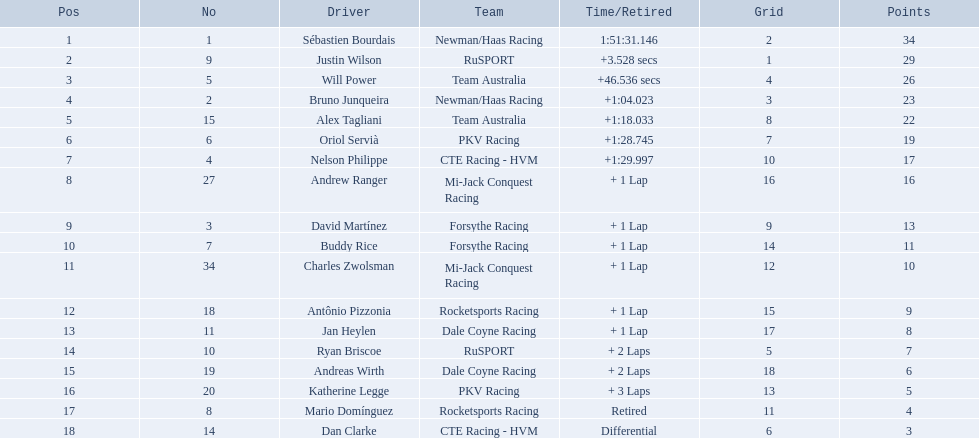Who are all of the 2006 gran premio telmex drivers? Sébastien Bourdais, Justin Wilson, Will Power, Bruno Junqueira, Alex Tagliani, Oriol Servià, Nelson Philippe, Andrew Ranger, David Martínez, Buddy Rice, Charles Zwolsman, Antônio Pizzonia, Jan Heylen, Ryan Briscoe, Andreas Wirth, Katherine Legge, Mario Domínguez, Dan Clarke. How many laps did they finish? 66, 66, 66, 66, 66, 66, 66, 65, 65, 65, 65, 65, 65, 64, 64, 63, 59, 7. What about just oriol servia and katherine legge? 66, 63. And which of those two drivers finished more laps? Oriol Servià. 